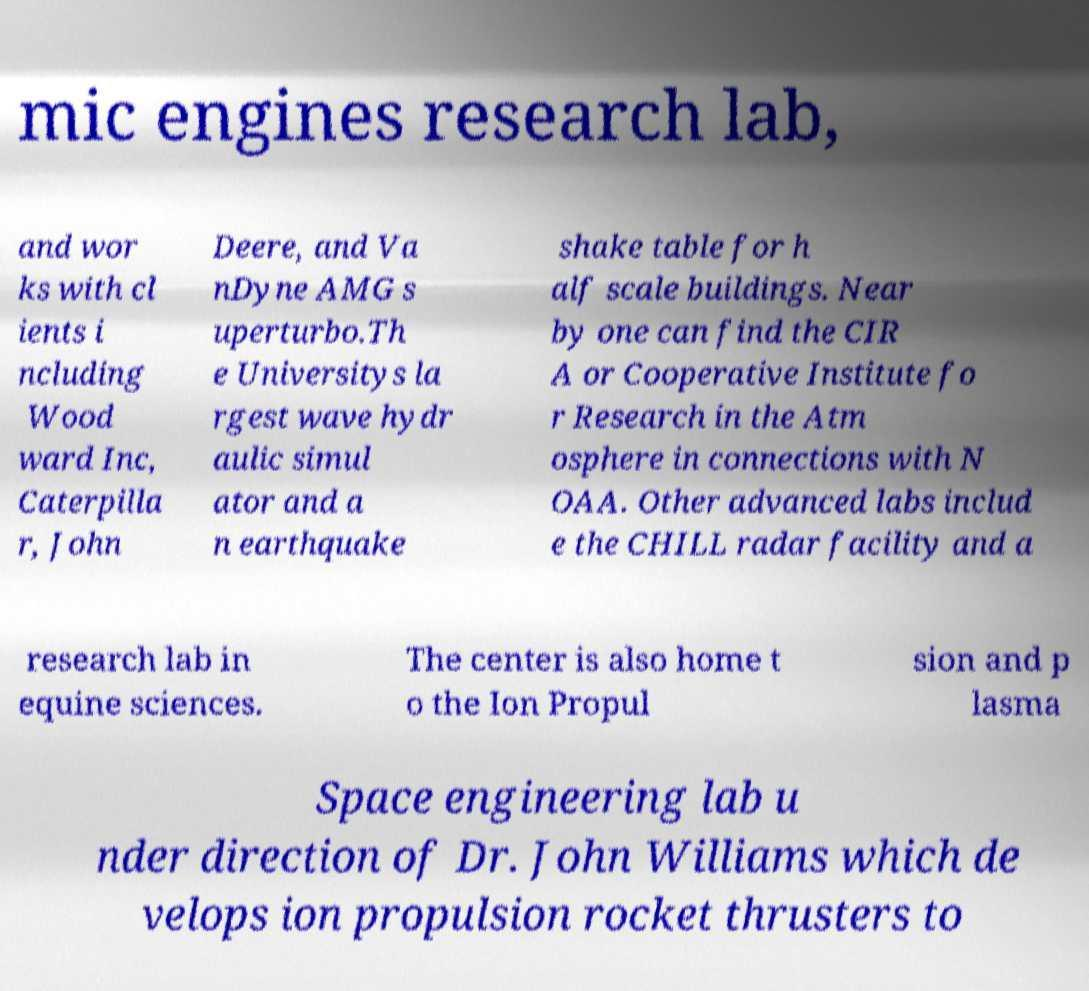What messages or text are displayed in this image? I need them in a readable, typed format. mic engines research lab, and wor ks with cl ients i ncluding Wood ward Inc, Caterpilla r, John Deere, and Va nDyne AMG s uperturbo.Th e Universitys la rgest wave hydr aulic simul ator and a n earthquake shake table for h alf scale buildings. Near by one can find the CIR A or Cooperative Institute fo r Research in the Atm osphere in connections with N OAA. Other advanced labs includ e the CHILL radar facility and a research lab in equine sciences. The center is also home t o the Ion Propul sion and p lasma Space engineering lab u nder direction of Dr. John Williams which de velops ion propulsion rocket thrusters to 